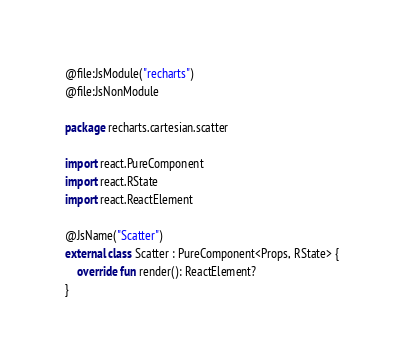<code> <loc_0><loc_0><loc_500><loc_500><_Kotlin_>@file:JsModule("recharts")
@file:JsNonModule

package recharts.cartesian.scatter

import react.PureComponent
import react.RState
import react.ReactElement

@JsName("Scatter")
external class Scatter : PureComponent<Props, RState> {
    override fun render(): ReactElement?
}
</code> 